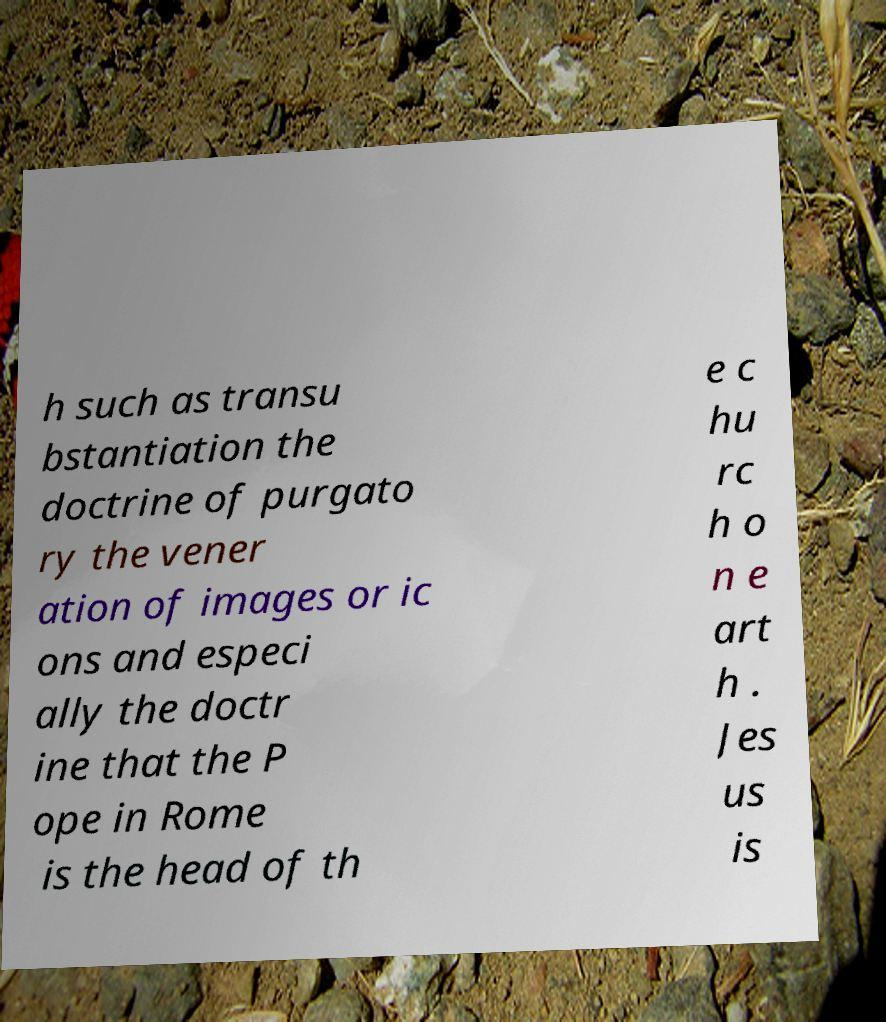Please identify and transcribe the text found in this image. h such as transu bstantiation the doctrine of purgato ry the vener ation of images or ic ons and especi ally the doctr ine that the P ope in Rome is the head of th e c hu rc h o n e art h . Jes us is 